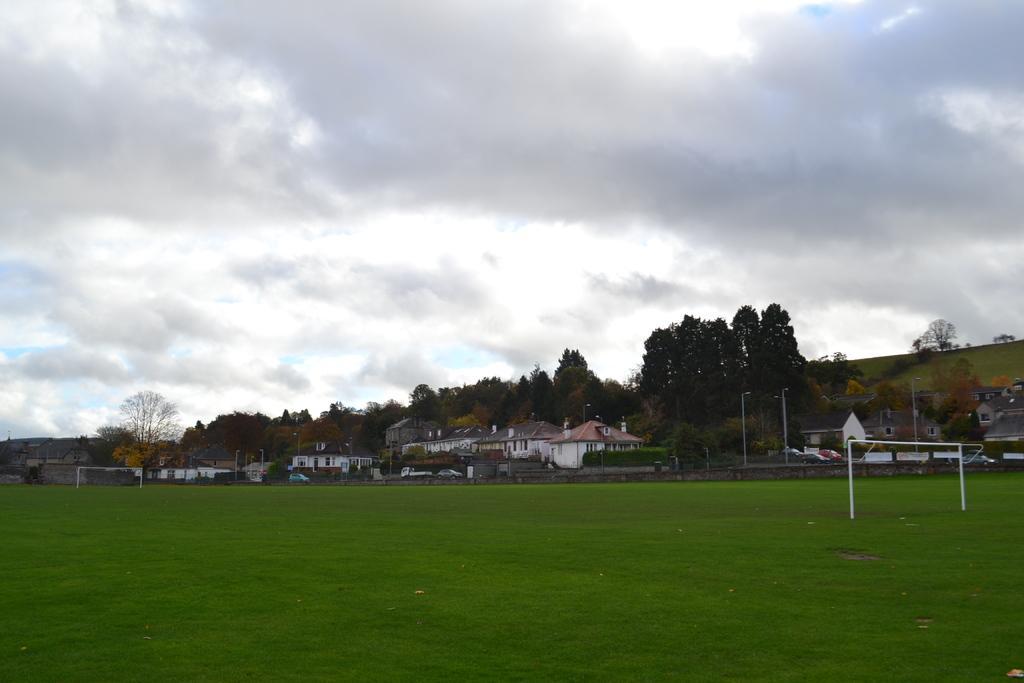Could you give a brief overview of what you see in this image? In this image I can see few building in white and gray color, background I can see trees in green color, sky in white and blue color. 